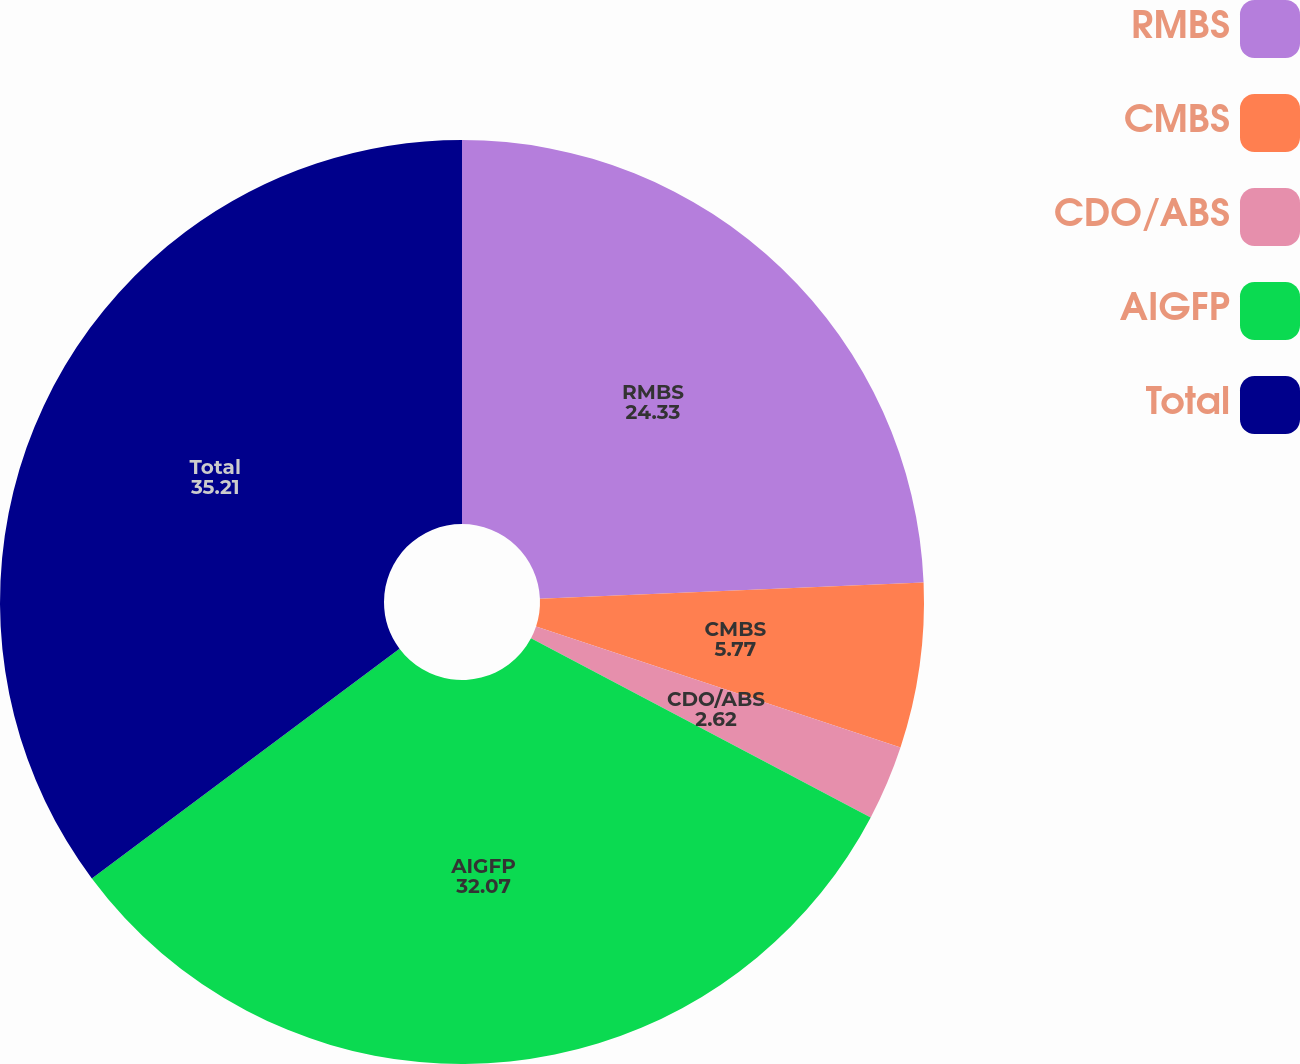<chart> <loc_0><loc_0><loc_500><loc_500><pie_chart><fcel>RMBS<fcel>CMBS<fcel>CDO/ABS<fcel>AIGFP<fcel>Total<nl><fcel>24.33%<fcel>5.77%<fcel>2.62%<fcel>32.07%<fcel>35.21%<nl></chart> 